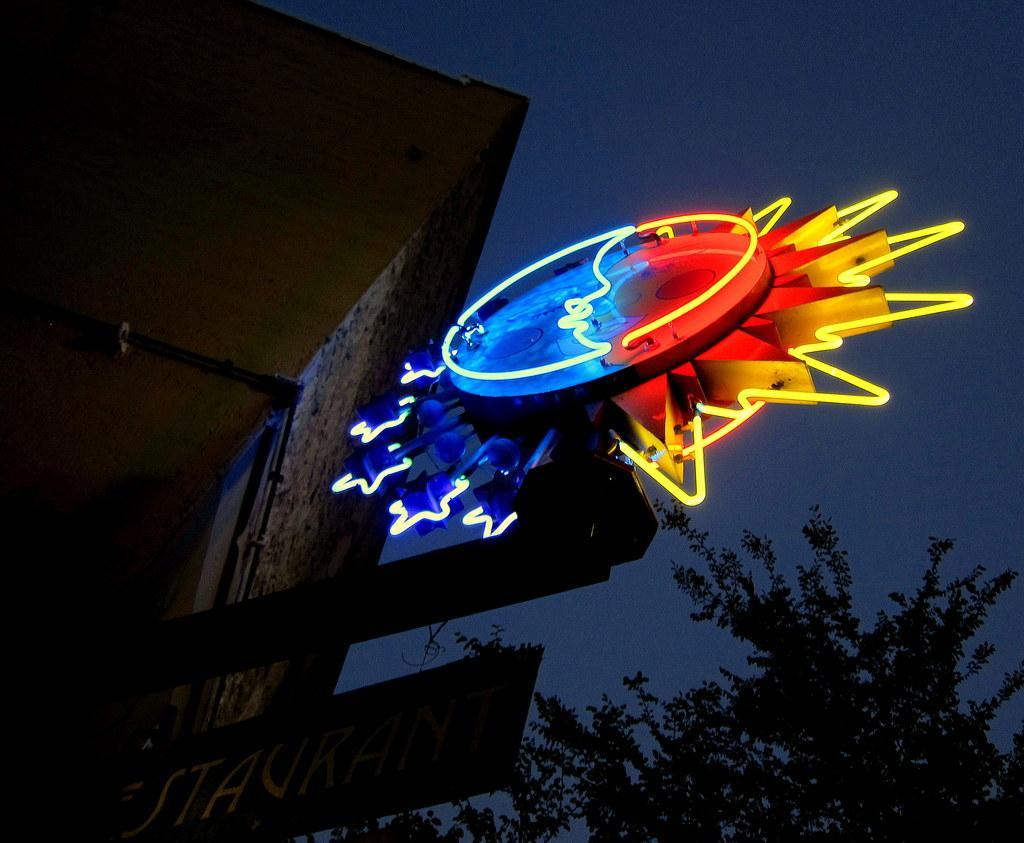Can you describe this image briefly? In this picture we can see a name board, tree, rods and an object and in the background we can see the sky. 